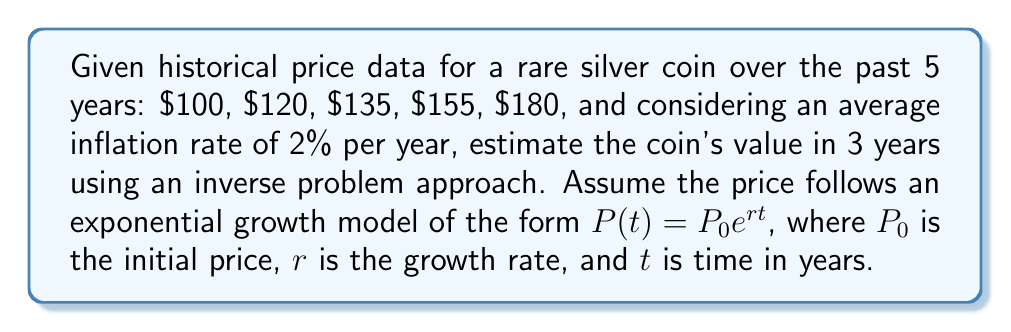What is the answer to this math problem? 1. First, we need to determine the growth rate $r$ using the given historical data:
   $$\frac{P_5}{P_0} = e^{5r}$$
   $$\frac{180}{100} = e^{5r}$$
   $$1.8 = e^{5r}$$
   $$\ln(1.8) = 5r$$
   $$r = \frac{\ln(1.8)}{5} \approx 0.1178$$

2. Now that we have $r$, we can use the exponential growth model to predict the price in 3 years:
   $$P(8) = 100e^{0.1178 \cdot 8} \approx 256.08$$

3. However, we need to account for inflation. The real growth rate is:
   $$r_{real} = r - \text{inflation rate} = 0.1178 - 0.02 = 0.0978$$

4. Using this real growth rate, we can predict the inflation-adjusted price:
   $$P_{real}(8) = 100e^{0.0978 \cdot 8} \approx 217.09$$

5. To solve the inverse problem and estimate the coin's value in 3 years, we need to project this value forward:
   $$P_{estimated}(3) = 217.09e^{0.0978 \cdot 3} \approx 259.24$$

6. Rounding to the nearest dollar gives us the final estimate.
Answer: $259 